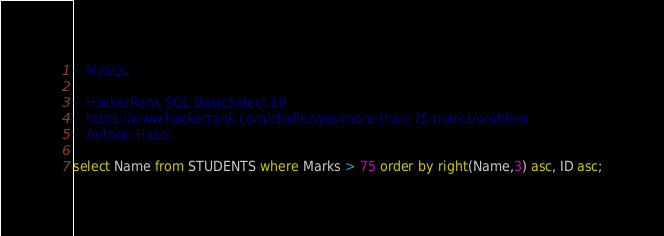Convert code to text. <code><loc_0><loc_0><loc_500><loc_500><_SQL_>-- MySQL

-- HackerRank SQL BasicSelect 18
-- https://www.hackerrank.com/challenges/more-than-75-marks/problem
-- Author: Hasol

select Name from STUDENTS where Marks > 75 order by right(Name,3) asc, ID asc;
</code> 